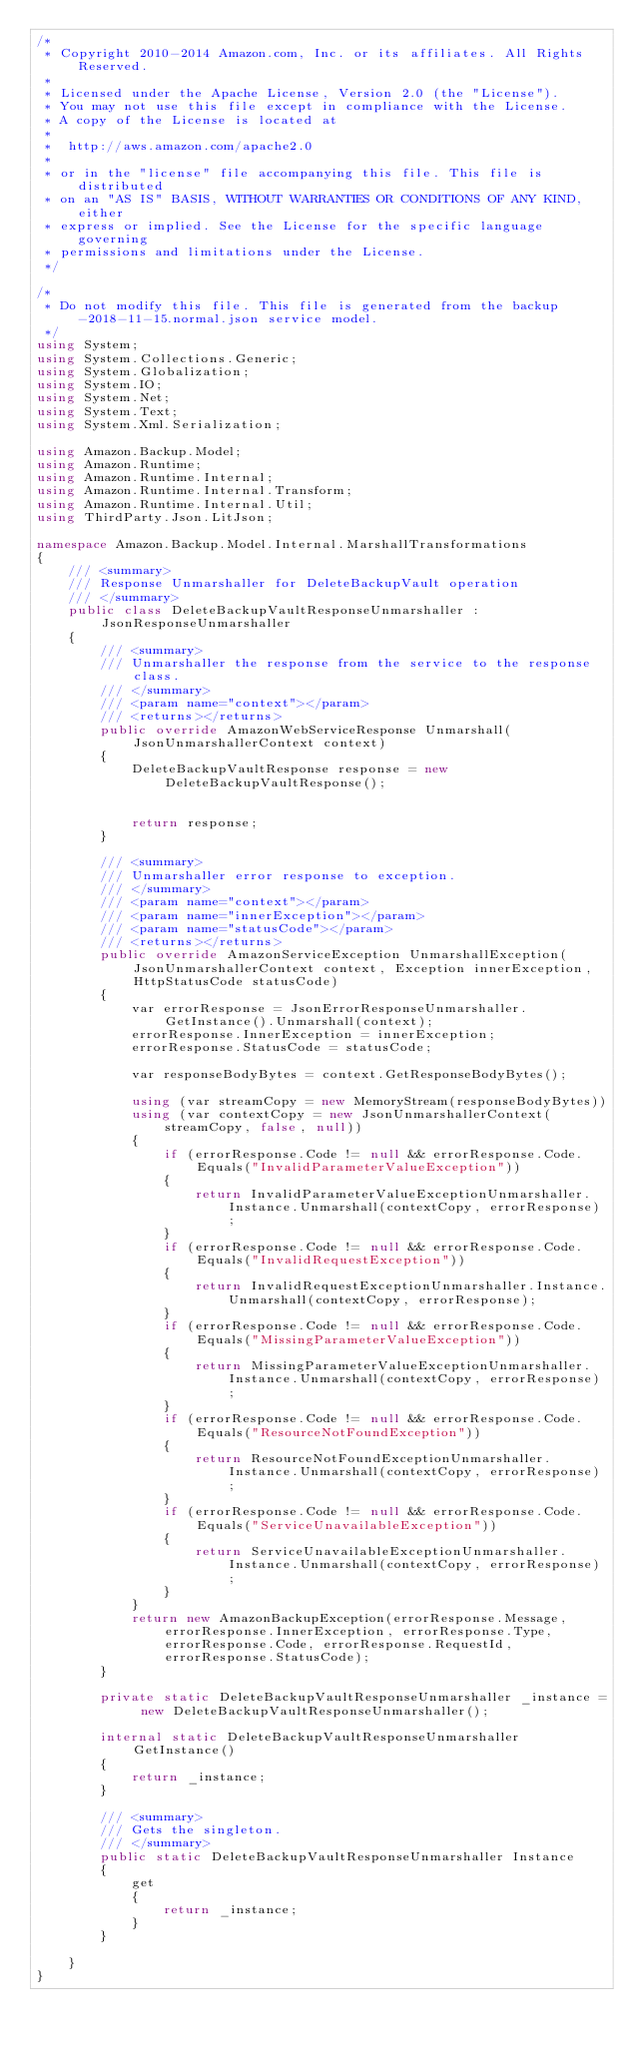<code> <loc_0><loc_0><loc_500><loc_500><_C#_>/*
 * Copyright 2010-2014 Amazon.com, Inc. or its affiliates. All Rights Reserved.
 * 
 * Licensed under the Apache License, Version 2.0 (the "License").
 * You may not use this file except in compliance with the License.
 * A copy of the License is located at
 * 
 *  http://aws.amazon.com/apache2.0
 * 
 * or in the "license" file accompanying this file. This file is distributed
 * on an "AS IS" BASIS, WITHOUT WARRANTIES OR CONDITIONS OF ANY KIND, either
 * express or implied. See the License for the specific language governing
 * permissions and limitations under the License.
 */

/*
 * Do not modify this file. This file is generated from the backup-2018-11-15.normal.json service model.
 */
using System;
using System.Collections.Generic;
using System.Globalization;
using System.IO;
using System.Net;
using System.Text;
using System.Xml.Serialization;

using Amazon.Backup.Model;
using Amazon.Runtime;
using Amazon.Runtime.Internal;
using Amazon.Runtime.Internal.Transform;
using Amazon.Runtime.Internal.Util;
using ThirdParty.Json.LitJson;

namespace Amazon.Backup.Model.Internal.MarshallTransformations
{
    /// <summary>
    /// Response Unmarshaller for DeleteBackupVault operation
    /// </summary>  
    public class DeleteBackupVaultResponseUnmarshaller : JsonResponseUnmarshaller
    {
        /// <summary>
        /// Unmarshaller the response from the service to the response class.
        /// </summary>  
        /// <param name="context"></param>
        /// <returns></returns>
        public override AmazonWebServiceResponse Unmarshall(JsonUnmarshallerContext context)
        {
            DeleteBackupVaultResponse response = new DeleteBackupVaultResponse();


            return response;
        }

        /// <summary>
        /// Unmarshaller error response to exception.
        /// </summary>  
        /// <param name="context"></param>
        /// <param name="innerException"></param>
        /// <param name="statusCode"></param>
        /// <returns></returns>
        public override AmazonServiceException UnmarshallException(JsonUnmarshallerContext context, Exception innerException, HttpStatusCode statusCode)
        {
            var errorResponse = JsonErrorResponseUnmarshaller.GetInstance().Unmarshall(context);
            errorResponse.InnerException = innerException;
            errorResponse.StatusCode = statusCode;

            var responseBodyBytes = context.GetResponseBodyBytes();

            using (var streamCopy = new MemoryStream(responseBodyBytes))
            using (var contextCopy = new JsonUnmarshallerContext(streamCopy, false, null))
            {
                if (errorResponse.Code != null && errorResponse.Code.Equals("InvalidParameterValueException"))
                {
                    return InvalidParameterValueExceptionUnmarshaller.Instance.Unmarshall(contextCopy, errorResponse);
                }
                if (errorResponse.Code != null && errorResponse.Code.Equals("InvalidRequestException"))
                {
                    return InvalidRequestExceptionUnmarshaller.Instance.Unmarshall(contextCopy, errorResponse);
                }
                if (errorResponse.Code != null && errorResponse.Code.Equals("MissingParameterValueException"))
                {
                    return MissingParameterValueExceptionUnmarshaller.Instance.Unmarshall(contextCopy, errorResponse);
                }
                if (errorResponse.Code != null && errorResponse.Code.Equals("ResourceNotFoundException"))
                {
                    return ResourceNotFoundExceptionUnmarshaller.Instance.Unmarshall(contextCopy, errorResponse);
                }
                if (errorResponse.Code != null && errorResponse.Code.Equals("ServiceUnavailableException"))
                {
                    return ServiceUnavailableExceptionUnmarshaller.Instance.Unmarshall(contextCopy, errorResponse);
                }
            }
            return new AmazonBackupException(errorResponse.Message, errorResponse.InnerException, errorResponse.Type, errorResponse.Code, errorResponse.RequestId, errorResponse.StatusCode);
        }

        private static DeleteBackupVaultResponseUnmarshaller _instance = new DeleteBackupVaultResponseUnmarshaller();        

        internal static DeleteBackupVaultResponseUnmarshaller GetInstance()
        {
            return _instance;
        }

        /// <summary>
        /// Gets the singleton.
        /// </summary>  
        public static DeleteBackupVaultResponseUnmarshaller Instance
        {
            get
            {
                return _instance;
            }
        }

    }
}</code> 